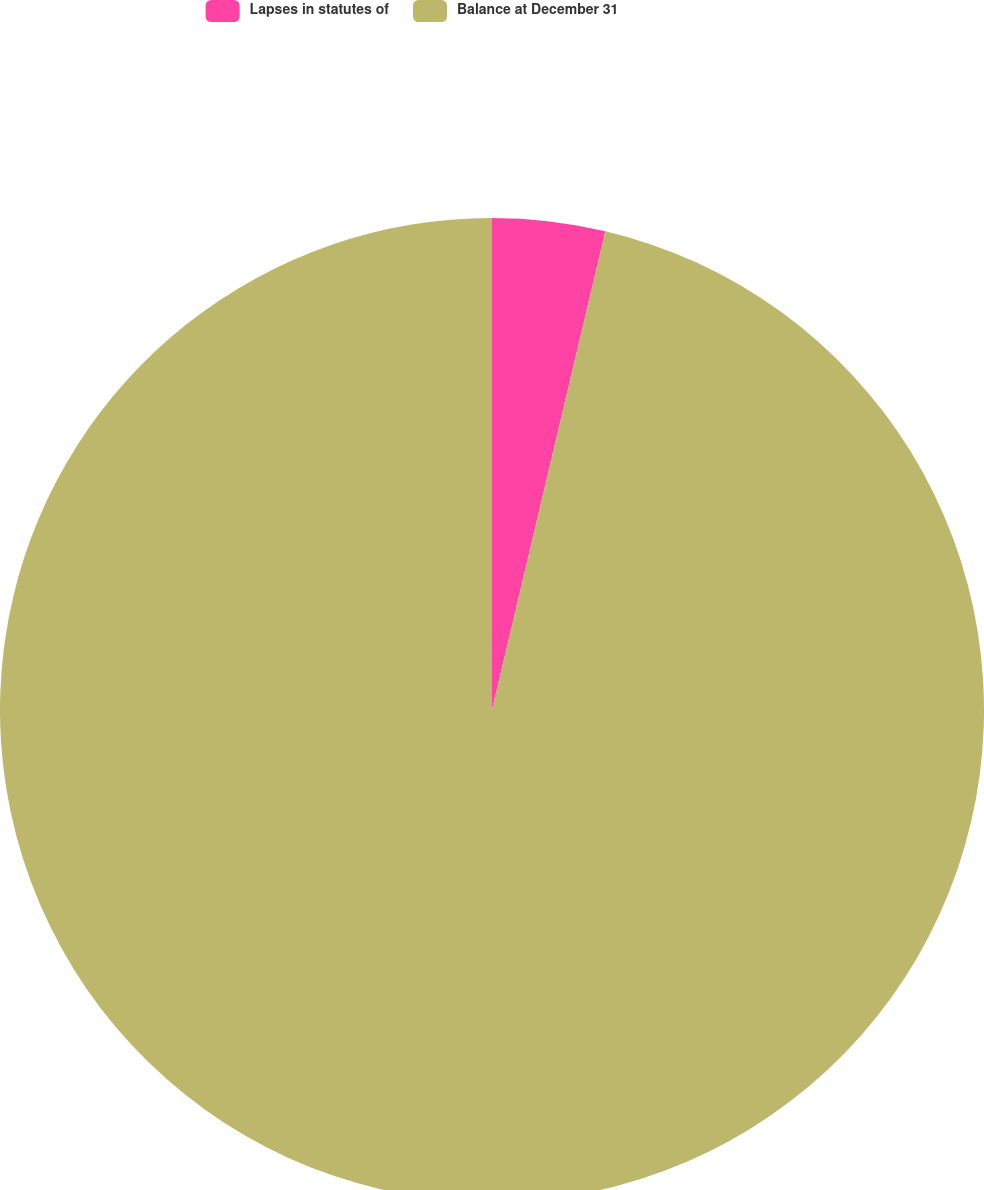Convert chart. <chart><loc_0><loc_0><loc_500><loc_500><pie_chart><fcel>Lapses in statutes of<fcel>Balance at December 31<nl><fcel>3.7%<fcel>96.3%<nl></chart> 